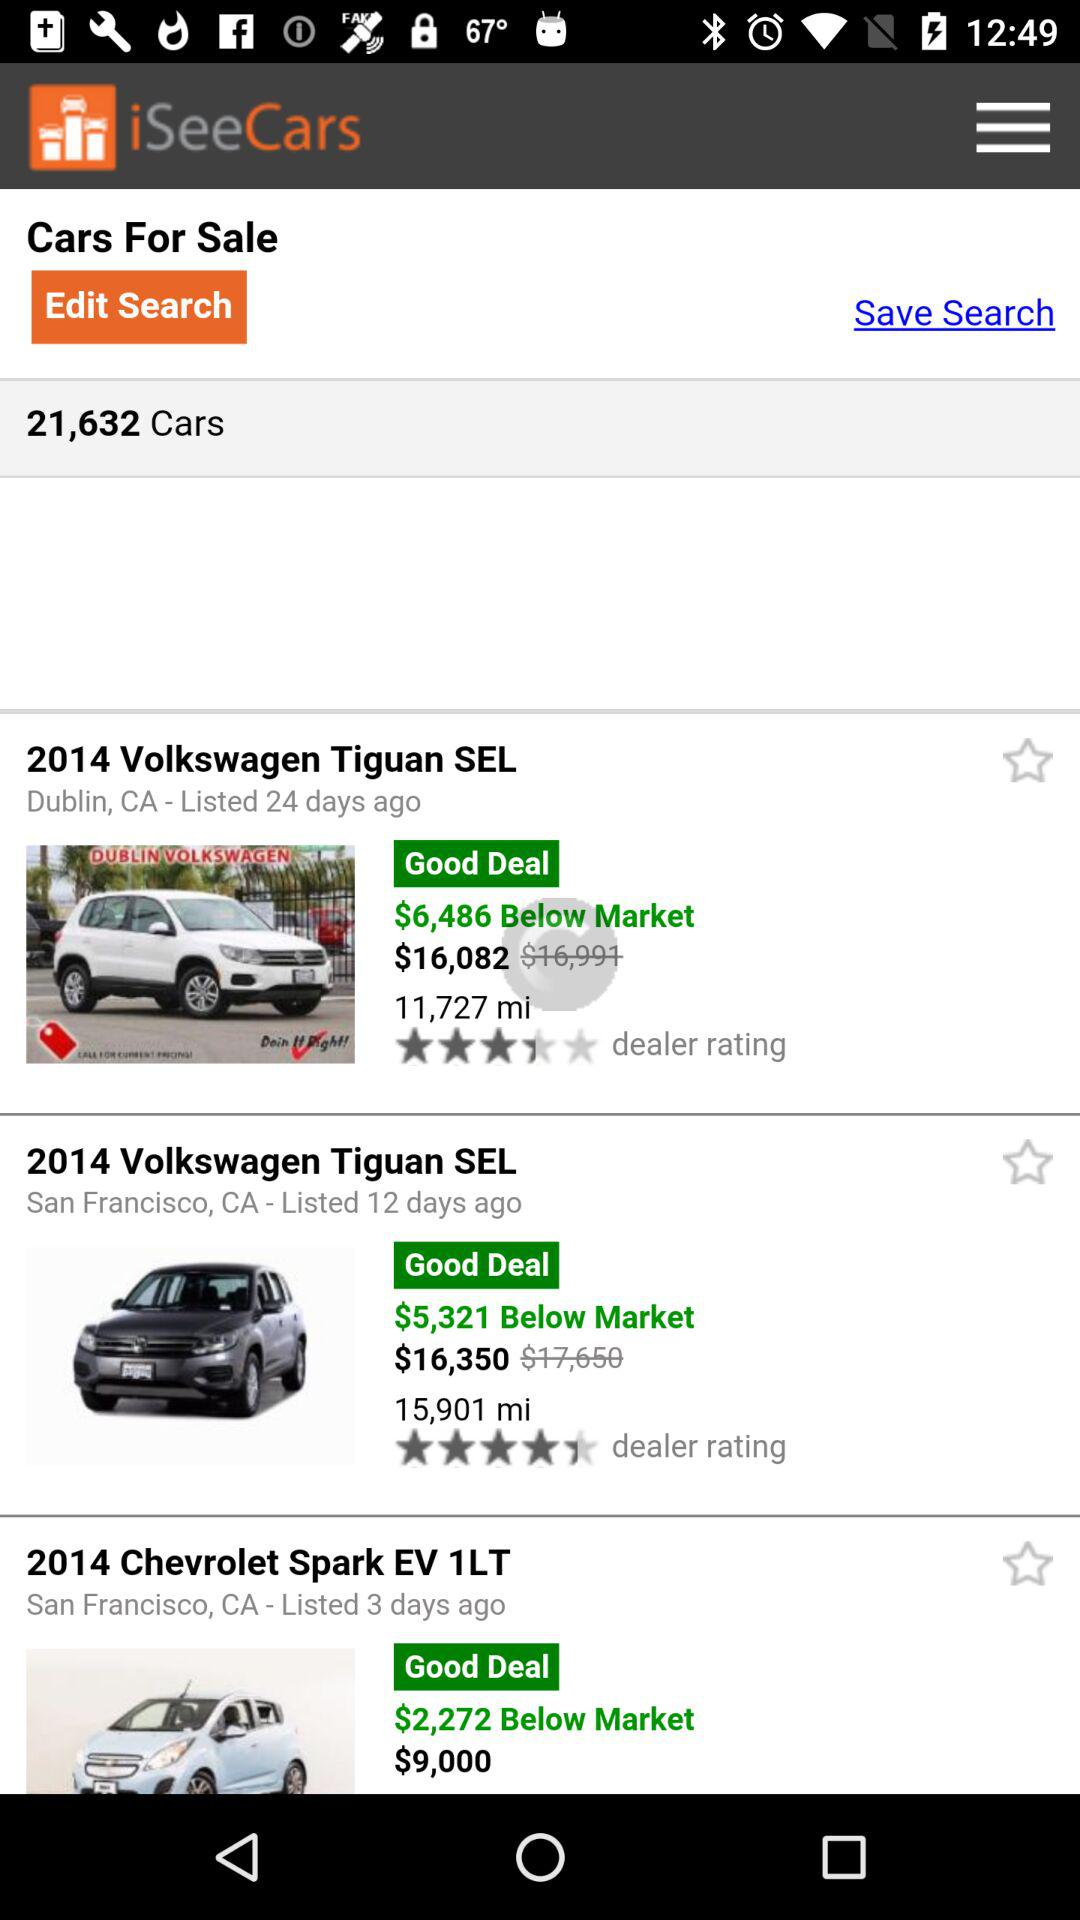What is the car count? The car count is 21,632. 